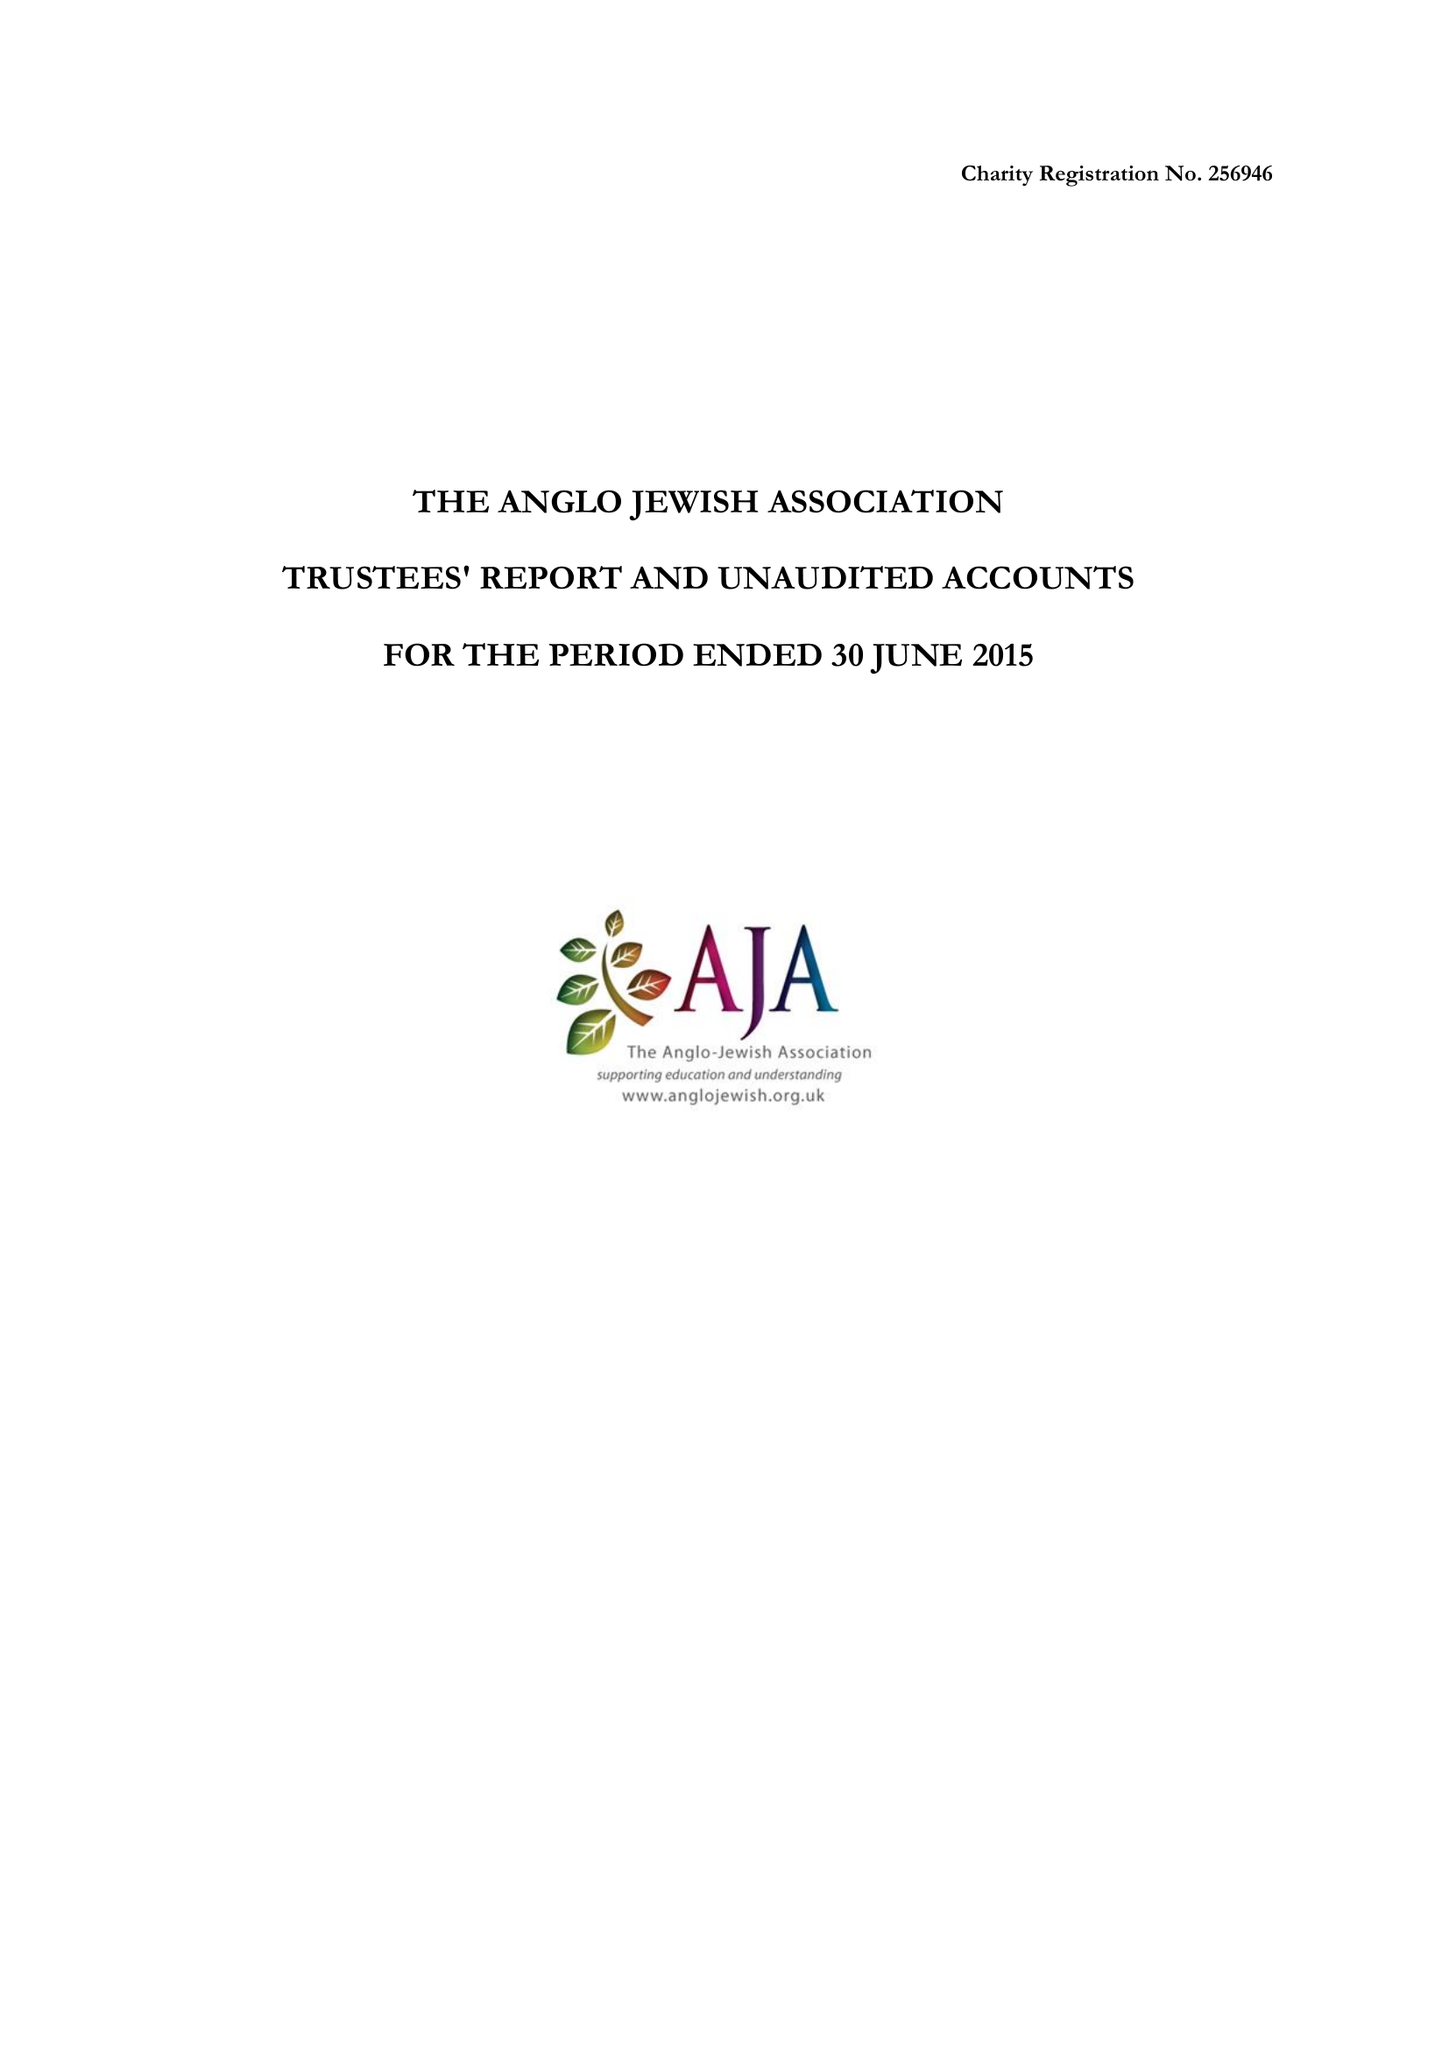What is the value for the address__postcode?
Answer the question using a single word or phrase. NW6 2EG 